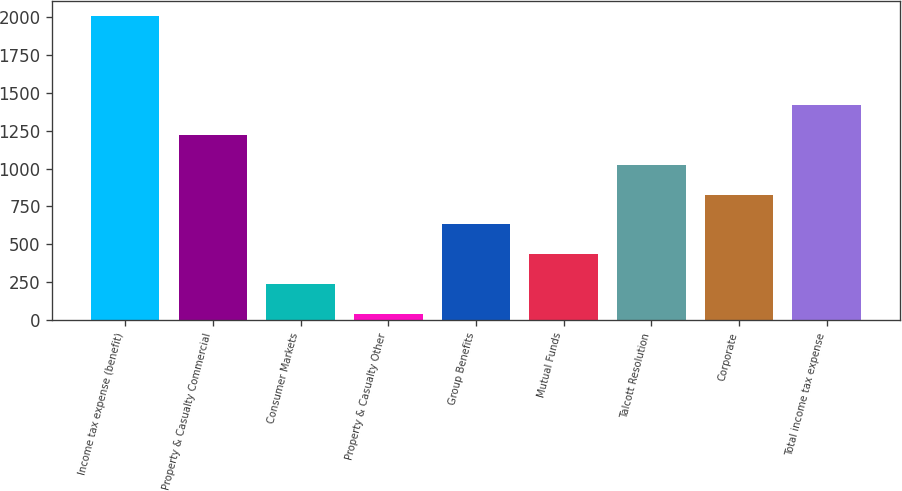Convert chart. <chart><loc_0><loc_0><loc_500><loc_500><bar_chart><fcel>Income tax expense (benefit)<fcel>Property & Casualty Commercial<fcel>Consumer Markets<fcel>Property & Casualty Other<fcel>Group Benefits<fcel>Mutual Funds<fcel>Talcott Resolution<fcel>Corporate<fcel>Total income tax expense<nl><fcel>2010<fcel>1222<fcel>237<fcel>40<fcel>631<fcel>434<fcel>1025<fcel>828<fcel>1419<nl></chart> 